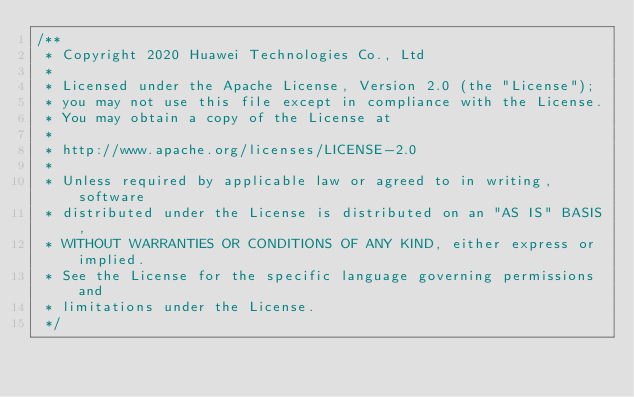<code> <loc_0><loc_0><loc_500><loc_500><_Cuda_>/**
 * Copyright 2020 Huawei Technologies Co., Ltd
 *
 * Licensed under the Apache License, Version 2.0 (the "License");
 * you may not use this file except in compliance with the License.
 * You may obtain a copy of the License at
 *
 * http://www.apache.org/licenses/LICENSE-2.0
 *
 * Unless required by applicable law or agreed to in writing, software
 * distributed under the License is distributed on an "AS IS" BASIS,
 * WITHOUT WARRANTIES OR CONDITIONS OF ANY KIND, either express or implied.
 * See the License for the specific language governing permissions and
 * limitations under the License.
 */
</code> 